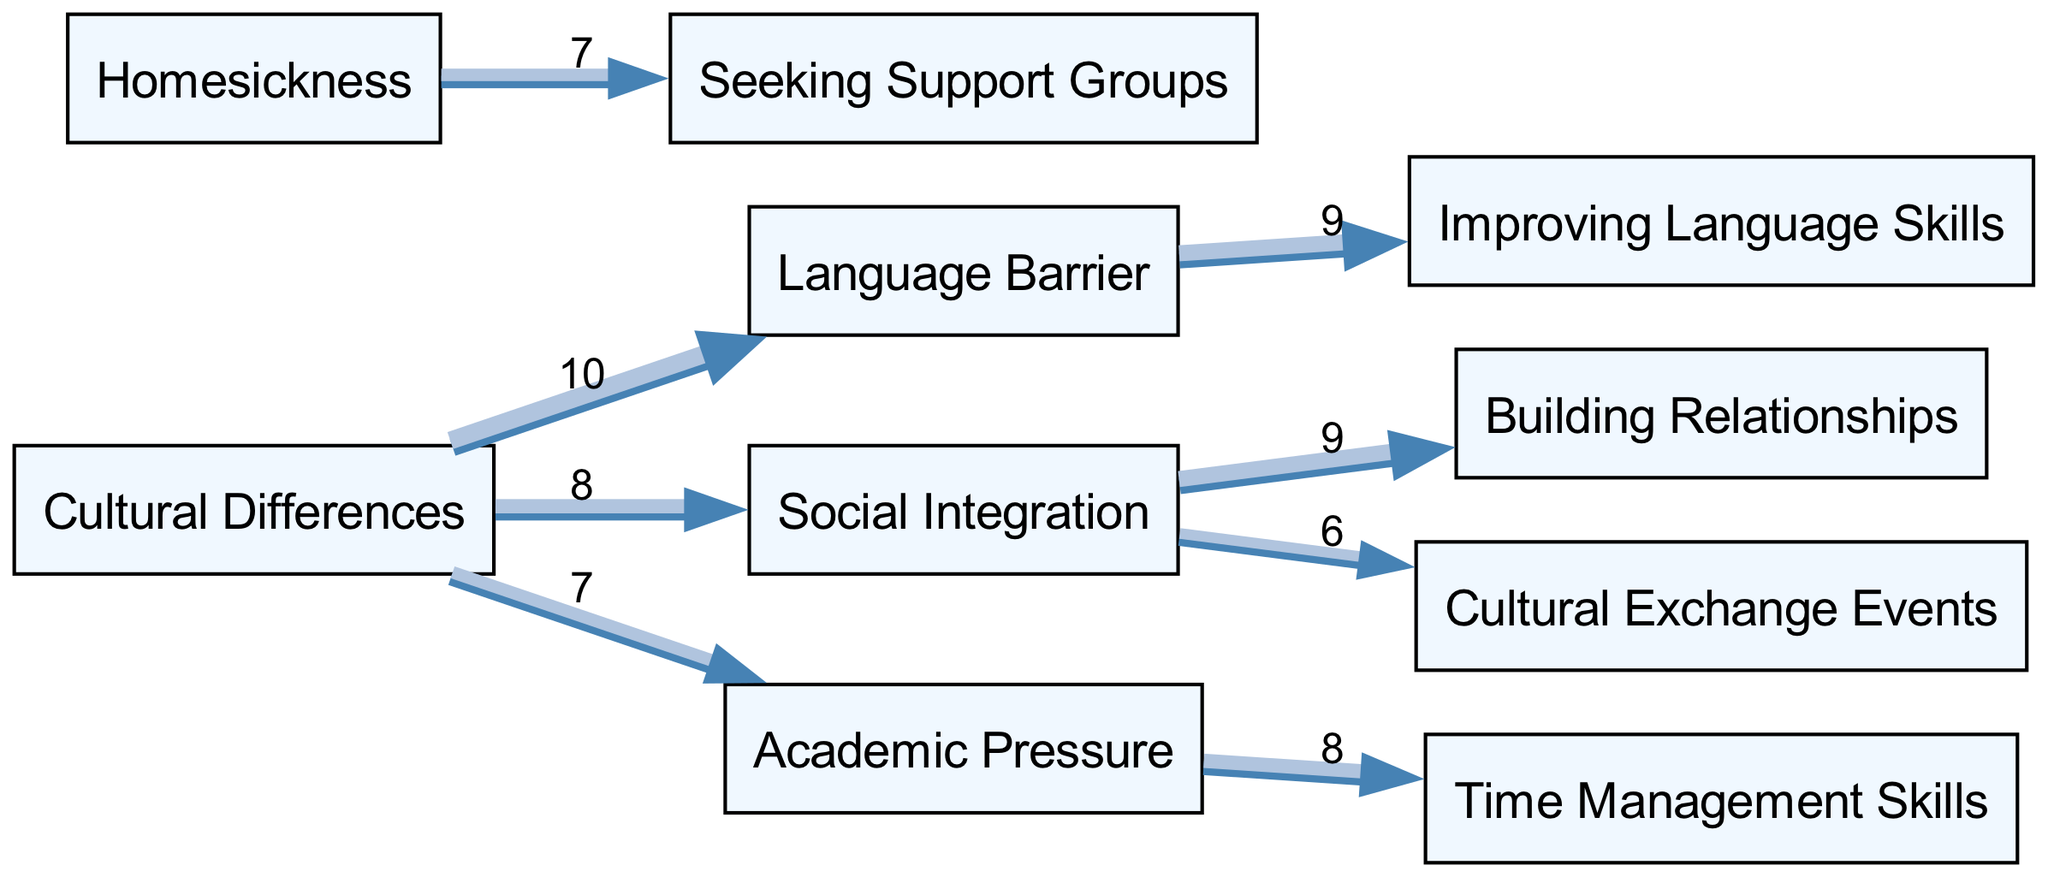What are the main sources of challenges depicted in the diagram? The diagram highlights four primary sources of challenges: Cultural Differences, Language Barrier, Social Integration, and Homesickness. These nodes are the starting points for various connections leading to other areas.
Answer: Cultural Differences, Language Barrier, Social Integration, Homesickness Which source is linked to the highest value of challenges? The connection from Cultural Differences to Language Barrier has the highest value of 10. This indicates that cultural differences significantly contribute to the language barrier faced by individuals adapting to a new culture.
Answer: 10 How many total nodes does the diagram contain? The diagram consists of ten nodes, which include both sources of challenges and methods to overcome them. A count of each unique node representing a concept or method gives us the total.
Answer: 10 What is the value of the link between Social Integration and Building Relationships? The value of the link between Social Integration and Building Relationships is 9, indicating a strong relationship between these two concepts where social integration significantly facilitates building relationships.
Answer: 9 Which method is associated with overcoming Academic Pressure? Time Management Skills is the method indicated to overcome Academic Pressure. The link shows that acquiring better time management skills can help alleviate the pressures experienced in an academic setting.
Answer: Time Management Skills What is the relationship between Language Barrier and Improving Language Skills? The link from Language Barrier to Improving Language Skills has a value of 9, suggesting that overcoming the language barrier is closely tied to improving one's ability to communicate in the new language.
Answer: 9 What is the total number of edges represented in the diagram? The total number of edges can be calculated by counting all the directed connections shown between the nodes. In this diagram, there are eight edges connecting various nodes.
Answer: 8 How does Homesickness connect to overcoming methods? Homesickness is linked to Seeking Support Groups with a value of 7, indicating that finding support through groups can effectively address feelings of homesickness.
Answer: Seeking Support Groups Which nodes are linked to the Cultural Differences node? Cultural Differences is linked to three nodes: Language Barrier, Social Integration, and Academic Pressure. Each indicates a different facet of challenges stemming from cultural differences.
Answer: Language Barrier, Social Integration, Academic Pressure 